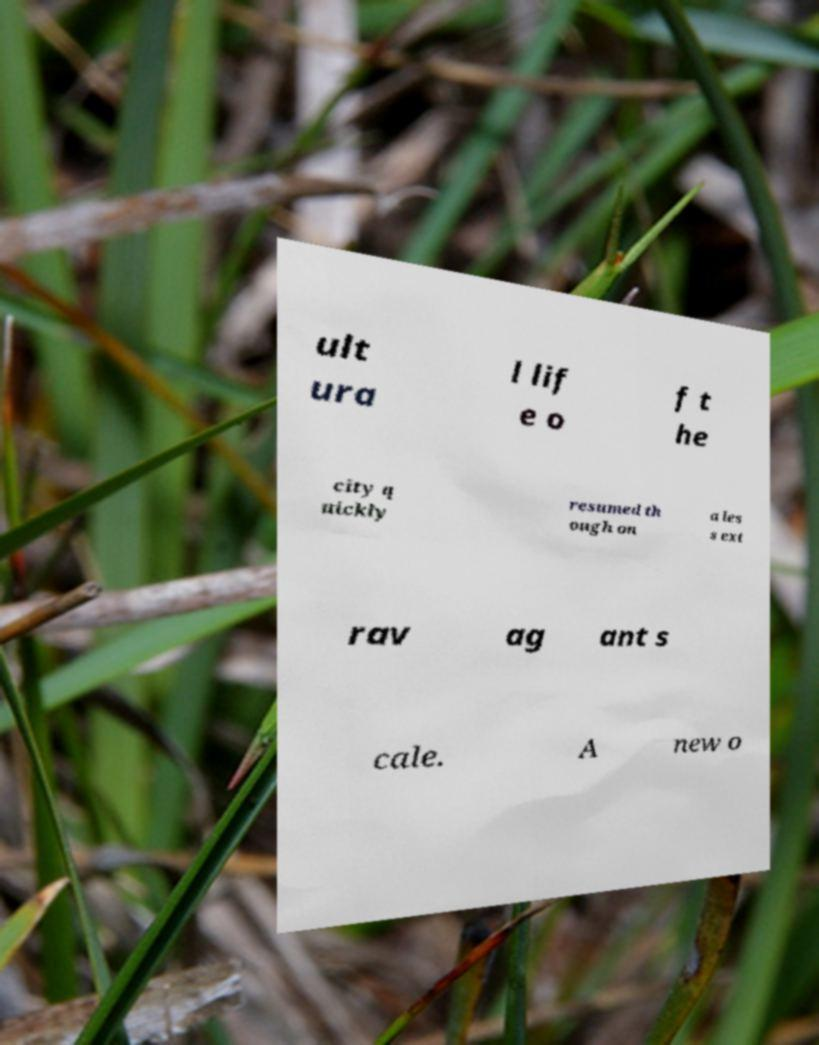Could you assist in decoding the text presented in this image and type it out clearly? ult ura l lif e o f t he city q uickly resumed th ough on a les s ext rav ag ant s cale. A new o 